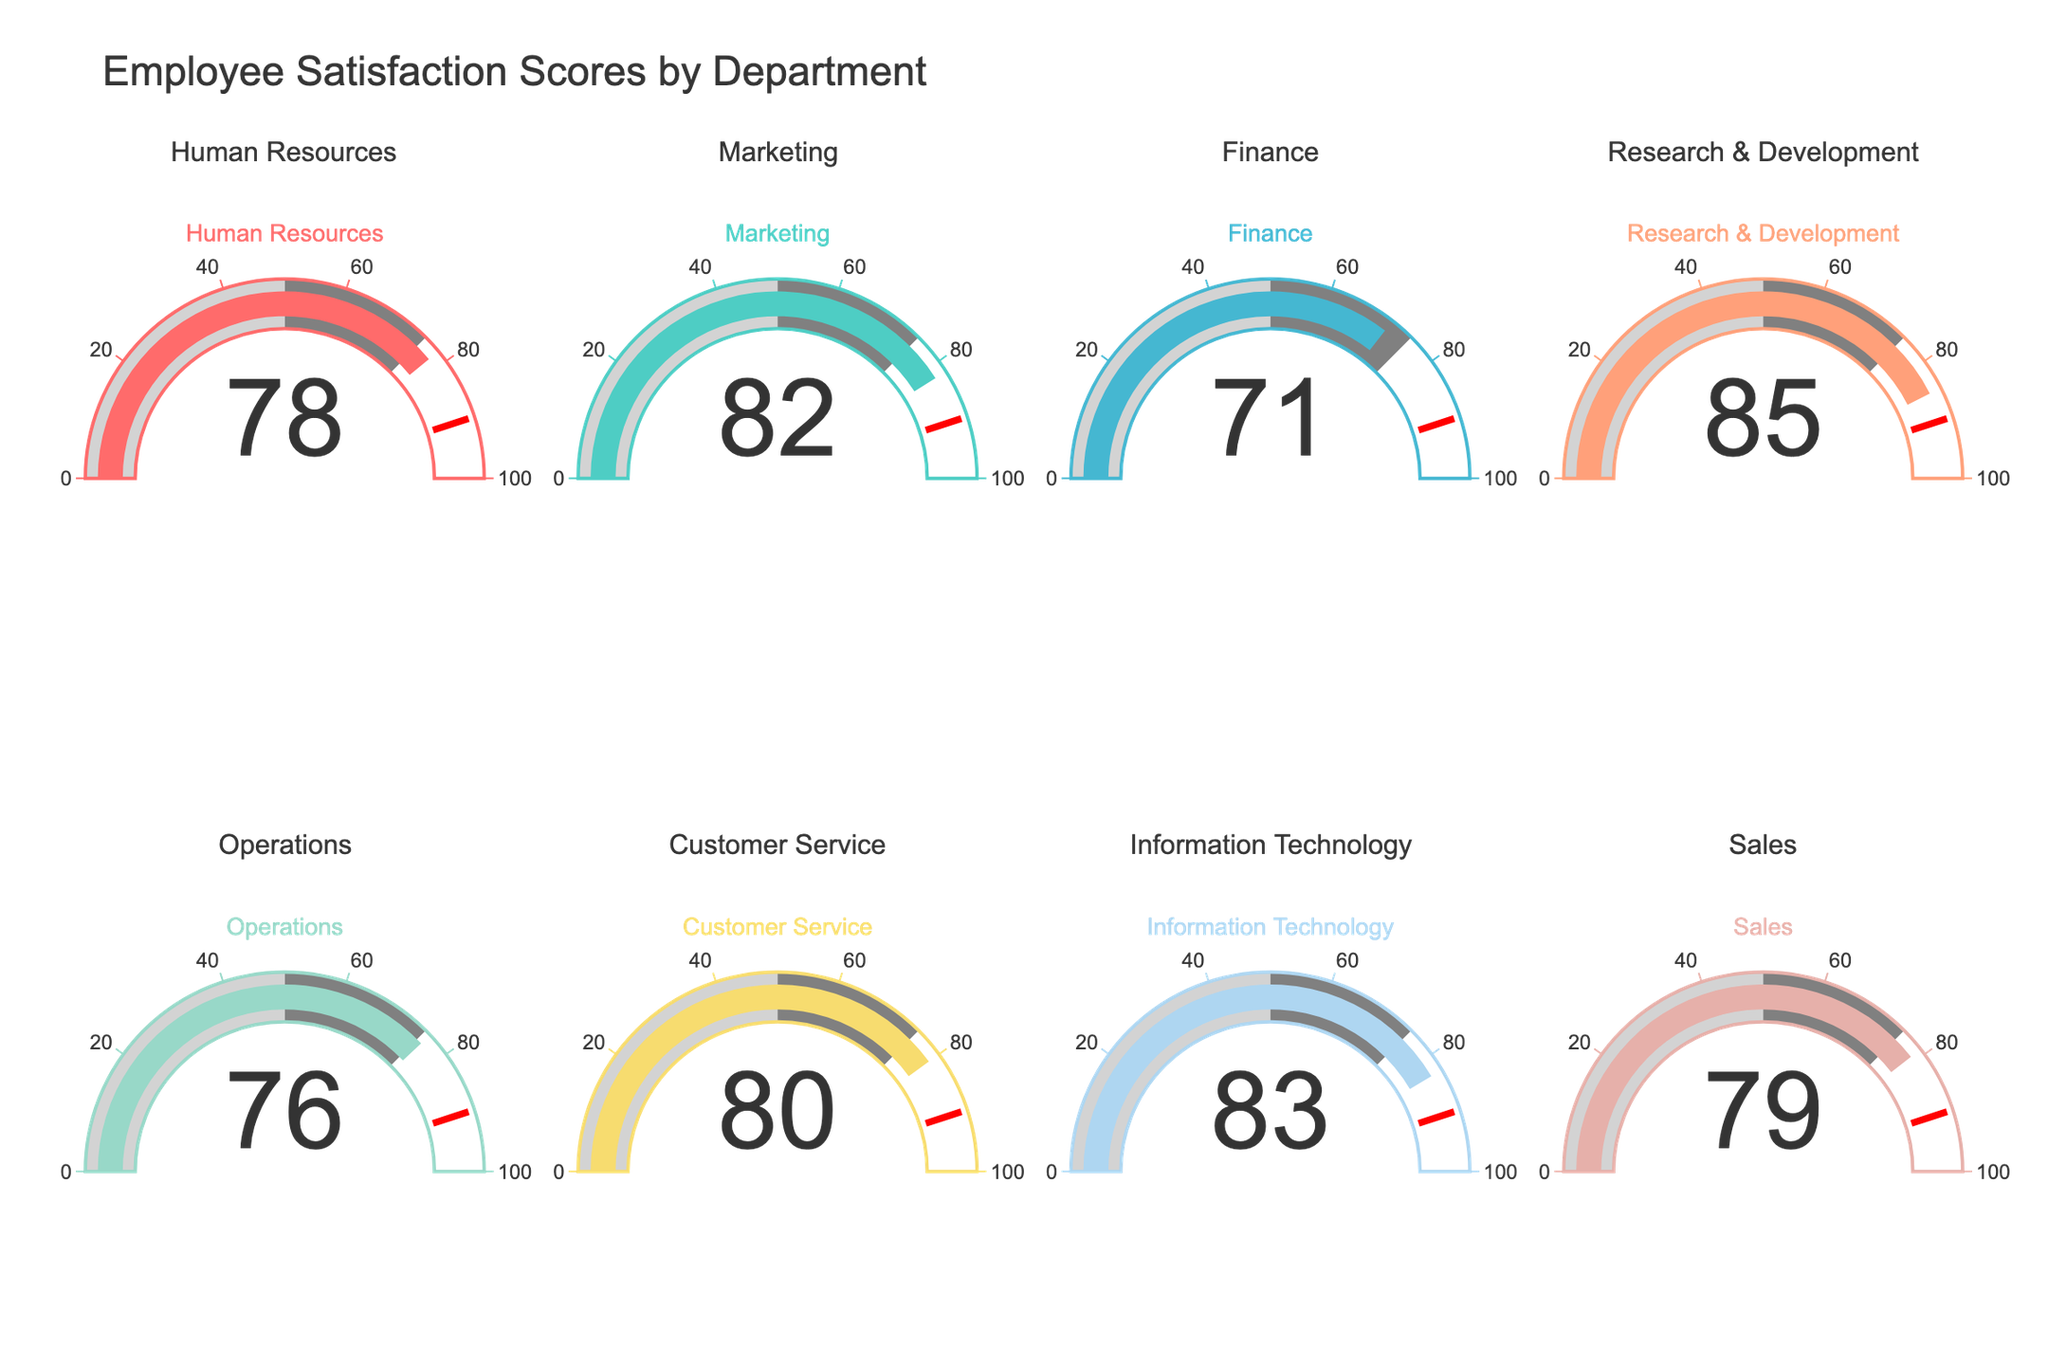What's the title of the chart? The title is presented at the top of the chart in a larger font size for emphasis.
Answer: Employee Satisfaction Scores by Department Which department has the highest satisfaction score? You need to look at the values displayed on the gauge charts for each department. The Research & Development department has the highest value at 85.
Answer: Research & Development Which department has the lowest satisfaction score? Check the values displayed on the gauge charts for each department. The Finance department has the lowest value at 71.
Answer: Finance What is the average satisfaction score across all departments? Add up all the satisfaction scores and divide by the number of departments: (78 + 82 + 71 + 85 + 76 + 80 + 83 + 79) / 8 = 634 / 8 = 79.25
Answer: 79.25 Is there any department with a satisfaction score above 80? If so, which ones? Look at the values on the gauge charts. The departments with scores above 80 are Marketing (82), Research & Development (85), and Information Technology (83).
Answer: Marketing, Research & Development, Information Technology What is the satisfaction score for the Operations department? Refer to the value displayed on the gauge chart for the Operations department.
Answer: 76 How much higher is the satisfaction score for Information Technology compared to Customer Service? Subtract the Customer Service score from the Information Technology score: 83 - 80 = 3
Answer: 3 Which departments have satisfaction scores between 75 and 80? Check the values on the gauge charts and identify those in the range 75-80. The departments are Human Resources (78), Operations (76), Sales (79).
Answer: Human Resources, Operations, Sales What's the difference between the highest and lowest satisfaction scores? Subtract the lowest score from the highest score: 85 - 71 = 14
Answer: 14 How many departments have satisfaction scores below 80? Count the number of departments with values less than 80. The departments are Human Resources, Finance, Operations, Sales.
Answer: 4 